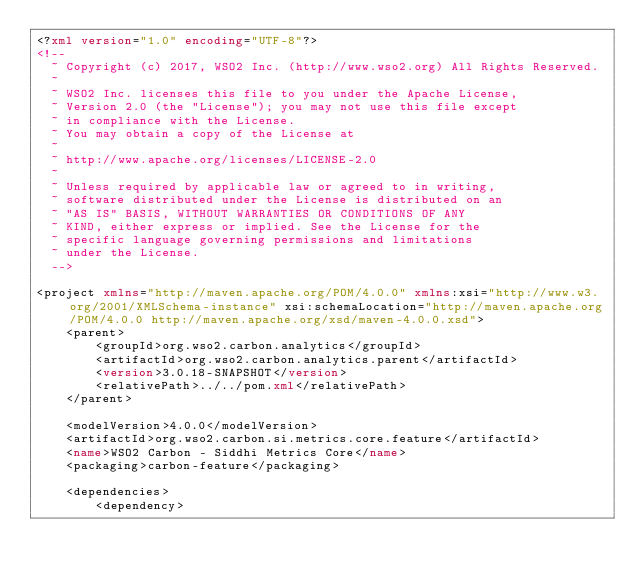Convert code to text. <code><loc_0><loc_0><loc_500><loc_500><_XML_><?xml version="1.0" encoding="UTF-8"?>
<!--
  ~ Copyright (c) 2017, WSO2 Inc. (http://www.wso2.org) All Rights Reserved.
  ~
  ~ WSO2 Inc. licenses this file to you under the Apache License,
  ~ Version 2.0 (the "License"); you may not use this file except
  ~ in compliance with the License.
  ~ You may obtain a copy of the License at
  ~
  ~ http://www.apache.org/licenses/LICENSE-2.0
  ~
  ~ Unless required by applicable law or agreed to in writing,
  ~ software distributed under the License is distributed on an
  ~ "AS IS" BASIS, WITHOUT WARRANTIES OR CONDITIONS OF ANY
  ~ KIND, either express or implied. See the License for the
  ~ specific language governing permissions and limitations
  ~ under the License.
  -->

<project xmlns="http://maven.apache.org/POM/4.0.0" xmlns:xsi="http://www.w3.org/2001/XMLSchema-instance" xsi:schemaLocation="http://maven.apache.org/POM/4.0.0 http://maven.apache.org/xsd/maven-4.0.0.xsd">
    <parent>
        <groupId>org.wso2.carbon.analytics</groupId>
        <artifactId>org.wso2.carbon.analytics.parent</artifactId>
        <version>3.0.18-SNAPSHOT</version>
        <relativePath>../../pom.xml</relativePath>
    </parent>

    <modelVersion>4.0.0</modelVersion>
    <artifactId>org.wso2.carbon.si.metrics.core.feature</artifactId>
    <name>WSO2 Carbon - Siddhi Metrics Core</name>
    <packaging>carbon-feature</packaging>

    <dependencies>
        <dependency></code> 